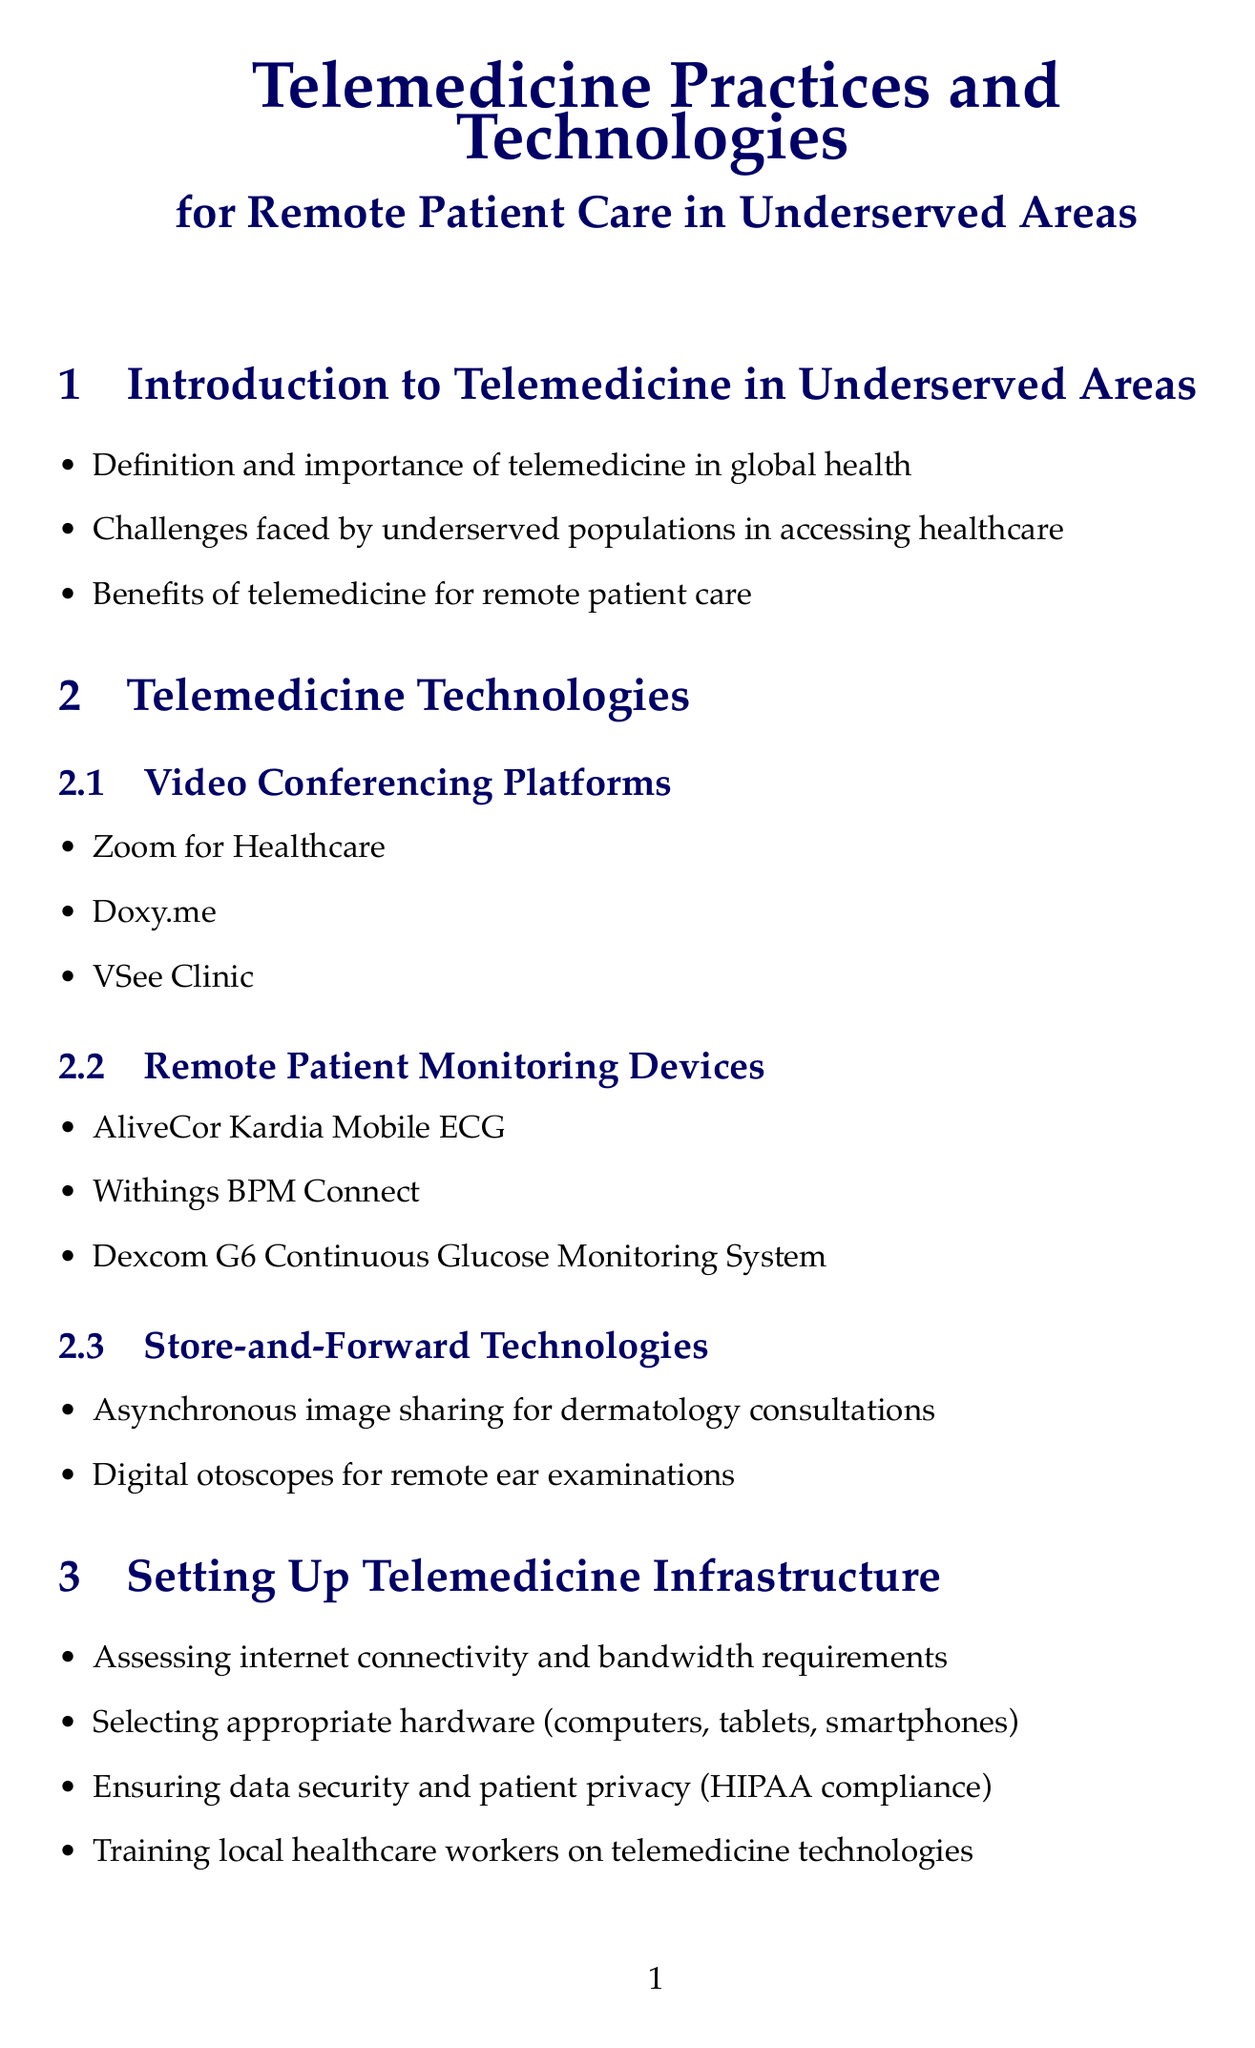What are the three types of telemedicine technologies mentioned? The document outlines three types of telemedicine technologies: Video Conferencing Platforms, Remote Patient Monitoring Devices, and Store-and-Forward Technologies.
Answer: Video Conferencing Platforms, Remote Patient Monitoring Devices, Store-and-Forward Technologies Which organization collaborated with Apollo Hospitals in India for telemedicine? The document highlights that Apollo Hospitals worked with the Indian Space Research Organisation (ISRO) on telemedicine centers.
Answer: Indian Space Research Organisation (ISRO) What is one benefit of telemedicine for remote patient care? The benefits of telemedicine for remote patient care are mentioned in the introductory section, but specific benefits are not detailed; students may need to infer from content.
Answer: Improved access to healthcare What is required for HIPAA compliance in telemedicine? Ensuring data security and patient privacy is necessary for maintaining HIPAA compliance, which is specified in the document.
Answer: Data security and patient privacy What is a future trend in global telemedicine related to technology? The document lists several future trends, including Artificial Intelligence in diagnostics, indicating a move towards advanced technologies in telemedicine practices.
Answer: Artificial Intelligence How does telemedicine address language barriers? Language barriers in telemedicine are addressed through the use of interpreters, highlighting a cultural consideration mentioned in the document.
Answer: Use of interpreters What is indicated as a protocol for emergency situations in telemedicine? The document states that protocols for emergency situations and referrals are crucial for clinical protocols in remote consultations.
Answer: Protocols for emergency situations What type of patient monitoring device is mentioned in the document? Specific examples of remote patient monitoring devices include AliveCor Kardia Mobile ECG, which is listed under telemedicine technologies.
Answer: AliveCor Kardia Mobile ECG What document provides guidelines for telemedicine? The document mentions the World Health Organization (WHO) Telemedicine Guidelines as a resource for further learning about telemedicine practices.
Answer: World Health Organization (WHO) Telemedicine Guidelines 